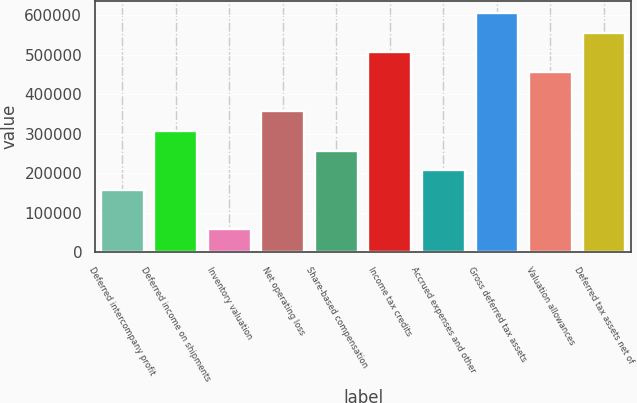Convert chart. <chart><loc_0><loc_0><loc_500><loc_500><bar_chart><fcel>Deferred intercompany profit<fcel>Deferred income on shipments<fcel>Inventory valuation<fcel>Net operating loss<fcel>Share-based compensation<fcel>Income tax credits<fcel>Accrued expenses and other<fcel>Gross deferred tax assets<fcel>Valuation allowances<fcel>Deferred tax assets net of<nl><fcel>157812<fcel>307109<fcel>58280.7<fcel>356875<fcel>257344<fcel>506172<fcel>207578<fcel>605703<fcel>456406<fcel>555938<nl></chart> 